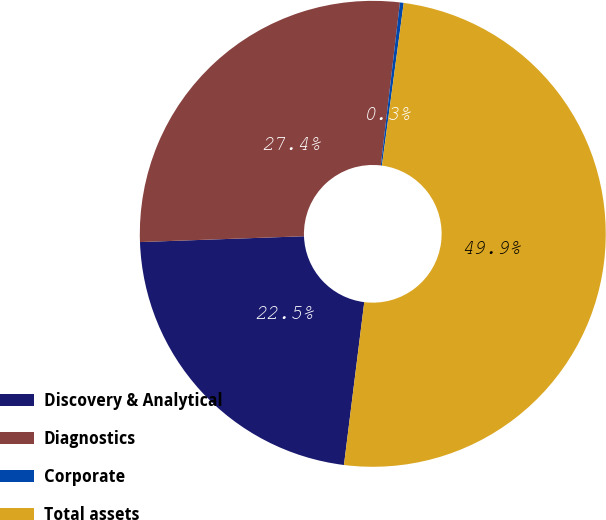<chart> <loc_0><loc_0><loc_500><loc_500><pie_chart><fcel>Discovery & Analytical<fcel>Diagnostics<fcel>Corporate<fcel>Total assets<nl><fcel>22.46%<fcel>27.42%<fcel>0.26%<fcel>49.85%<nl></chart> 